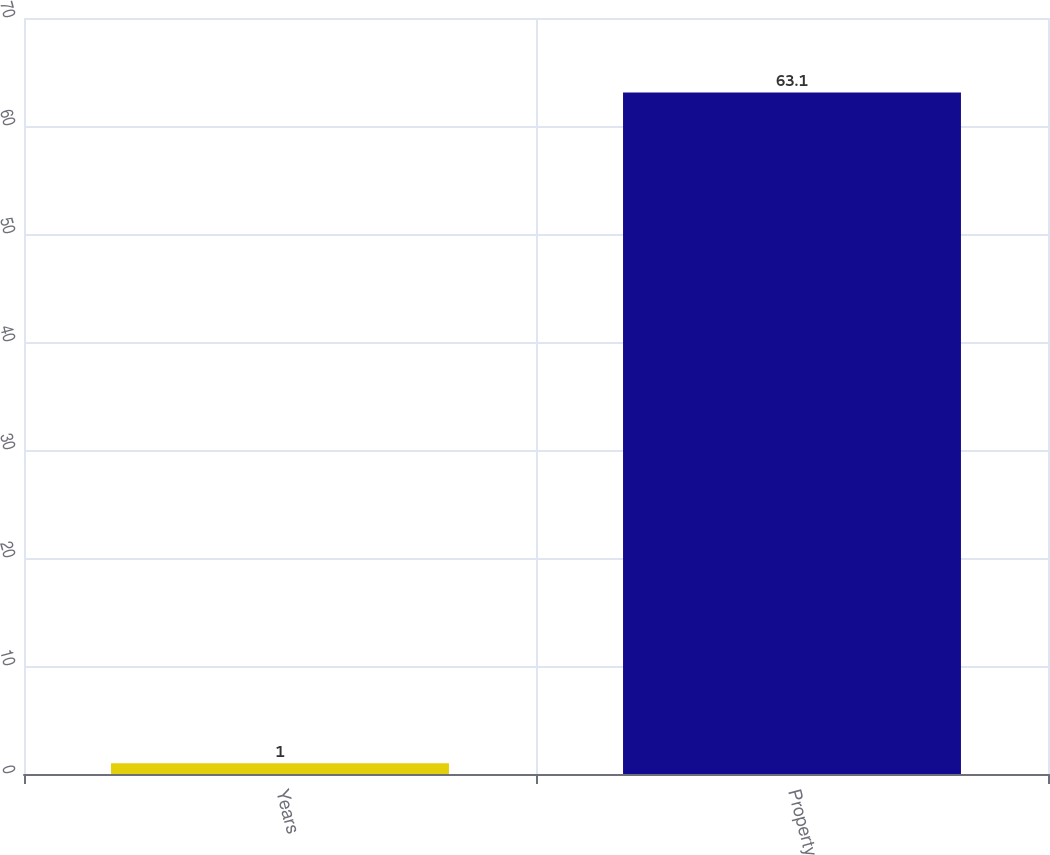Convert chart to OTSL. <chart><loc_0><loc_0><loc_500><loc_500><bar_chart><fcel>Years<fcel>Property<nl><fcel>1<fcel>63.1<nl></chart> 